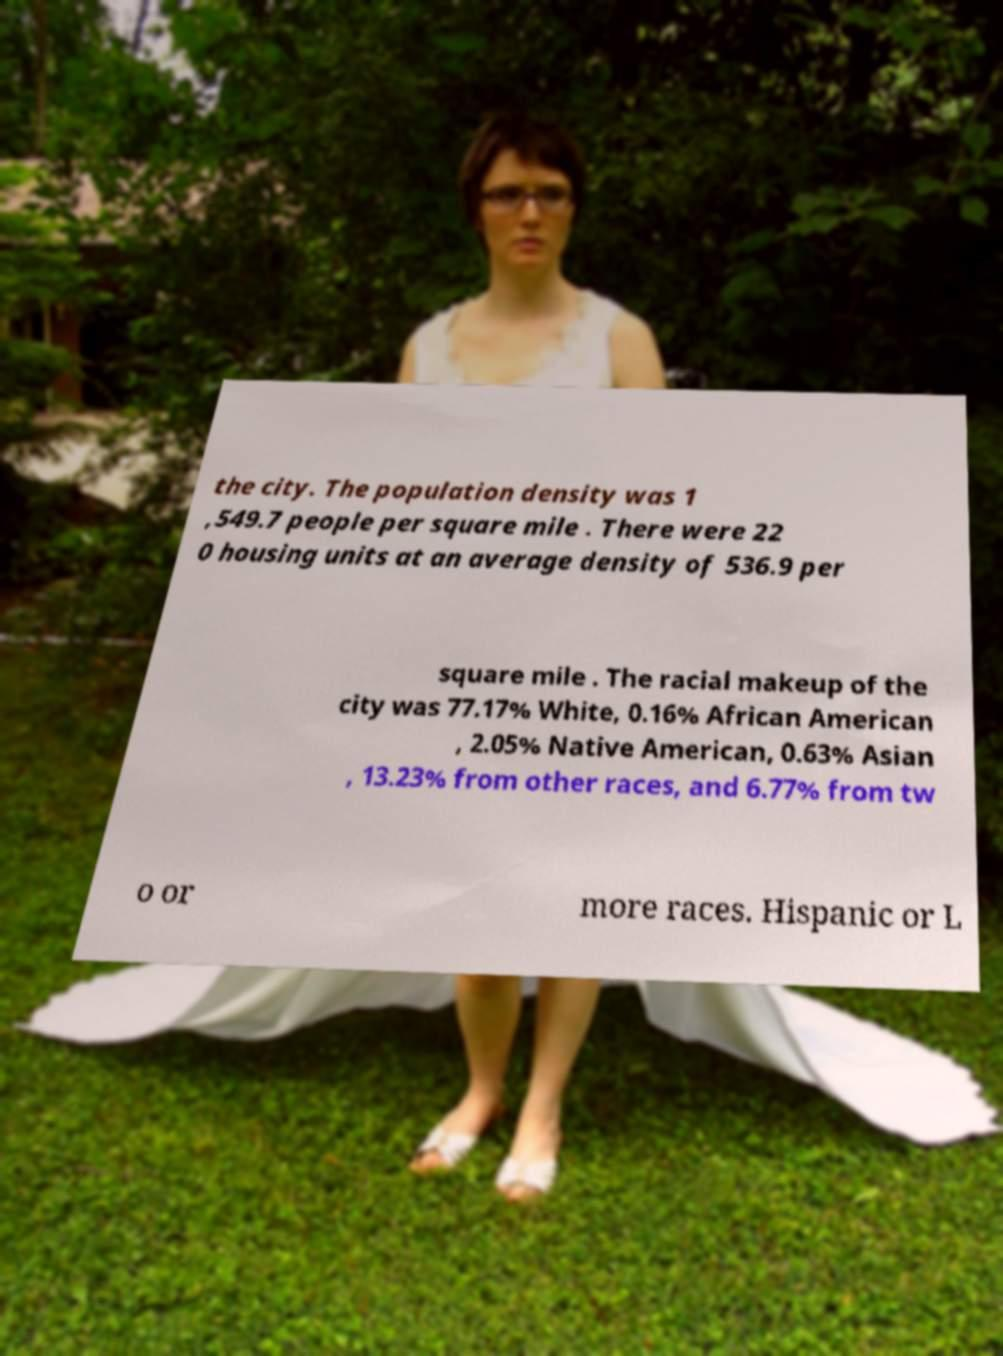Could you extract and type out the text from this image? the city. The population density was 1 ,549.7 people per square mile . There were 22 0 housing units at an average density of 536.9 per square mile . The racial makeup of the city was 77.17% White, 0.16% African American , 2.05% Native American, 0.63% Asian , 13.23% from other races, and 6.77% from tw o or more races. Hispanic or L 